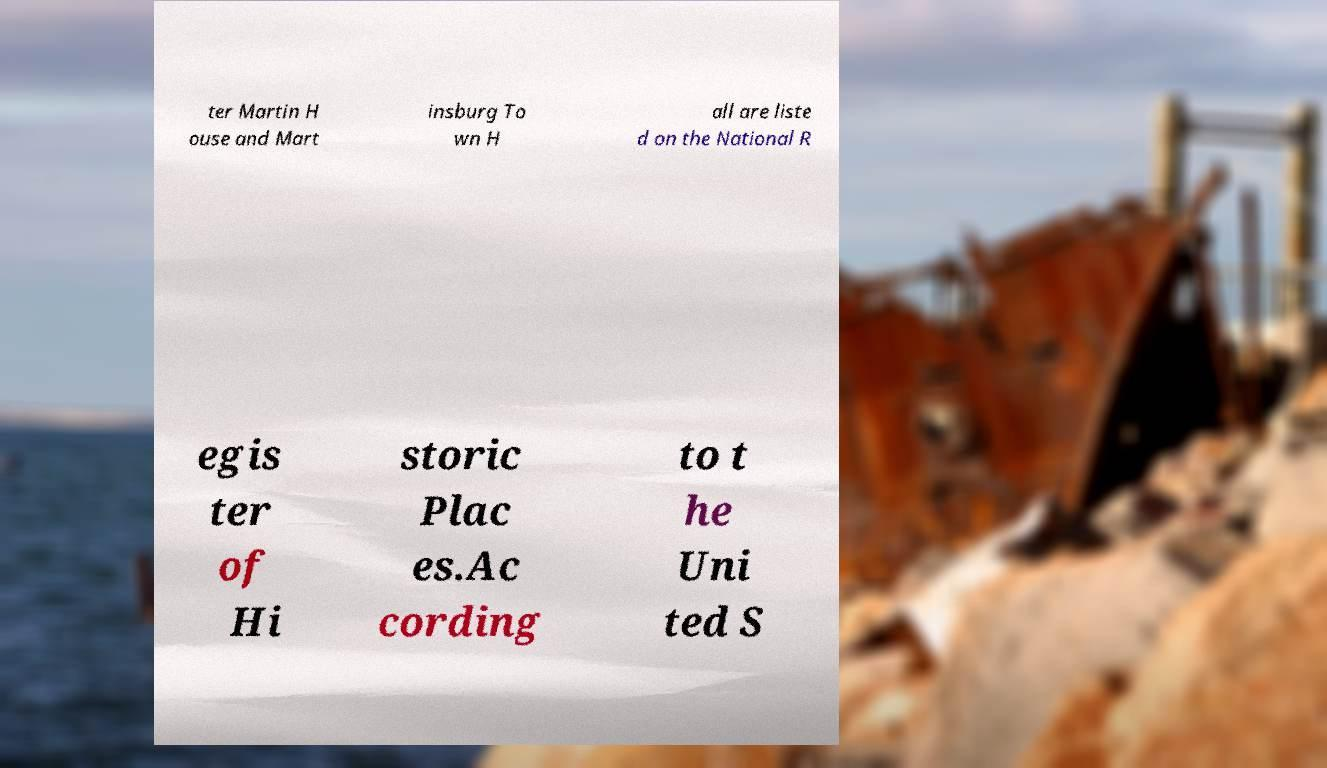Could you extract and type out the text from this image? ter Martin H ouse and Mart insburg To wn H all are liste d on the National R egis ter of Hi storic Plac es.Ac cording to t he Uni ted S 